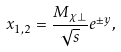<formula> <loc_0><loc_0><loc_500><loc_500>x _ { 1 , 2 } = \frac { M _ { \chi \perp } } { \sqrt { s } } e ^ { \pm y } ,</formula> 